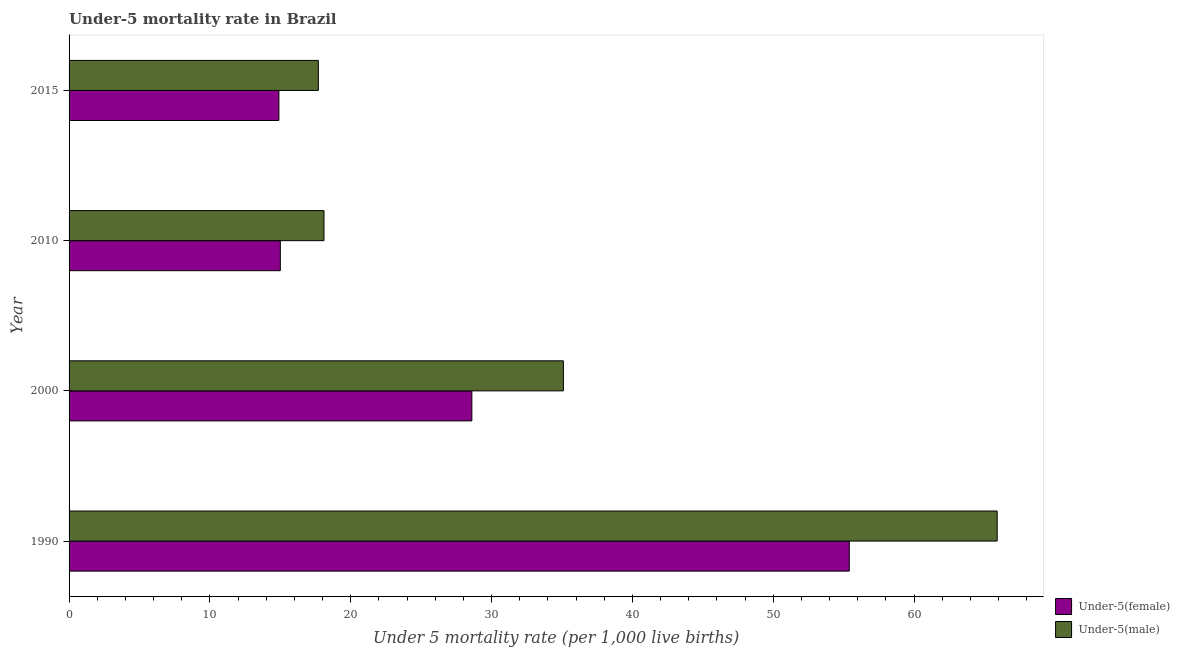How many different coloured bars are there?
Provide a short and direct response. 2. How many groups of bars are there?
Offer a terse response. 4. Are the number of bars on each tick of the Y-axis equal?
Your response must be concise. Yes. How many bars are there on the 2nd tick from the bottom?
Your answer should be compact. 2. What is the under-5 male mortality rate in 2015?
Keep it short and to the point. 17.7. Across all years, what is the maximum under-5 female mortality rate?
Provide a short and direct response. 55.4. Across all years, what is the minimum under-5 female mortality rate?
Make the answer very short. 14.9. In which year was the under-5 female mortality rate minimum?
Make the answer very short. 2015. What is the total under-5 male mortality rate in the graph?
Ensure brevity in your answer.  136.8. What is the difference between the under-5 male mortality rate in 1990 and that in 2000?
Your answer should be compact. 30.8. What is the difference between the under-5 male mortality rate in 2010 and the under-5 female mortality rate in 2000?
Your response must be concise. -10.5. What is the average under-5 female mortality rate per year?
Ensure brevity in your answer.  28.48. What is the ratio of the under-5 female mortality rate in 1990 to that in 2000?
Your answer should be compact. 1.94. What is the difference between the highest and the second highest under-5 male mortality rate?
Your response must be concise. 30.8. What is the difference between the highest and the lowest under-5 male mortality rate?
Keep it short and to the point. 48.2. Is the sum of the under-5 female mortality rate in 1990 and 2010 greater than the maximum under-5 male mortality rate across all years?
Your response must be concise. Yes. What does the 1st bar from the top in 2010 represents?
Offer a very short reply. Under-5(male). What does the 2nd bar from the bottom in 2000 represents?
Keep it short and to the point. Under-5(male). Are all the bars in the graph horizontal?
Offer a very short reply. Yes. How many years are there in the graph?
Keep it short and to the point. 4. Are the values on the major ticks of X-axis written in scientific E-notation?
Ensure brevity in your answer.  No. What is the title of the graph?
Offer a terse response. Under-5 mortality rate in Brazil. What is the label or title of the X-axis?
Offer a very short reply. Under 5 mortality rate (per 1,0 live births). What is the Under 5 mortality rate (per 1,000 live births) of Under-5(female) in 1990?
Offer a very short reply. 55.4. What is the Under 5 mortality rate (per 1,000 live births) of Under-5(male) in 1990?
Provide a succinct answer. 65.9. What is the Under 5 mortality rate (per 1,000 live births) of Under-5(female) in 2000?
Offer a terse response. 28.6. What is the Under 5 mortality rate (per 1,000 live births) of Under-5(male) in 2000?
Give a very brief answer. 35.1. What is the Under 5 mortality rate (per 1,000 live births) in Under-5(female) in 2010?
Give a very brief answer. 15. What is the Under 5 mortality rate (per 1,000 live births) in Under-5(female) in 2015?
Give a very brief answer. 14.9. Across all years, what is the maximum Under 5 mortality rate (per 1,000 live births) of Under-5(female)?
Give a very brief answer. 55.4. Across all years, what is the maximum Under 5 mortality rate (per 1,000 live births) in Under-5(male)?
Your answer should be very brief. 65.9. Across all years, what is the minimum Under 5 mortality rate (per 1,000 live births) of Under-5(male)?
Your answer should be very brief. 17.7. What is the total Under 5 mortality rate (per 1,000 live births) of Under-5(female) in the graph?
Offer a very short reply. 113.9. What is the total Under 5 mortality rate (per 1,000 live births) of Under-5(male) in the graph?
Your answer should be compact. 136.8. What is the difference between the Under 5 mortality rate (per 1,000 live births) in Under-5(female) in 1990 and that in 2000?
Your answer should be compact. 26.8. What is the difference between the Under 5 mortality rate (per 1,000 live births) of Under-5(male) in 1990 and that in 2000?
Give a very brief answer. 30.8. What is the difference between the Under 5 mortality rate (per 1,000 live births) of Under-5(female) in 1990 and that in 2010?
Provide a short and direct response. 40.4. What is the difference between the Under 5 mortality rate (per 1,000 live births) in Under-5(male) in 1990 and that in 2010?
Make the answer very short. 47.8. What is the difference between the Under 5 mortality rate (per 1,000 live births) in Under-5(female) in 1990 and that in 2015?
Provide a succinct answer. 40.5. What is the difference between the Under 5 mortality rate (per 1,000 live births) in Under-5(male) in 1990 and that in 2015?
Offer a terse response. 48.2. What is the difference between the Under 5 mortality rate (per 1,000 live births) in Under-5(female) in 2000 and that in 2010?
Provide a short and direct response. 13.6. What is the difference between the Under 5 mortality rate (per 1,000 live births) in Under-5(male) in 2000 and that in 2010?
Ensure brevity in your answer.  17. What is the difference between the Under 5 mortality rate (per 1,000 live births) of Under-5(female) in 2000 and that in 2015?
Keep it short and to the point. 13.7. What is the difference between the Under 5 mortality rate (per 1,000 live births) in Under-5(male) in 2000 and that in 2015?
Keep it short and to the point. 17.4. What is the difference between the Under 5 mortality rate (per 1,000 live births) in Under-5(female) in 2010 and that in 2015?
Ensure brevity in your answer.  0.1. What is the difference between the Under 5 mortality rate (per 1,000 live births) in Under-5(female) in 1990 and the Under 5 mortality rate (per 1,000 live births) in Under-5(male) in 2000?
Offer a terse response. 20.3. What is the difference between the Under 5 mortality rate (per 1,000 live births) of Under-5(female) in 1990 and the Under 5 mortality rate (per 1,000 live births) of Under-5(male) in 2010?
Offer a very short reply. 37.3. What is the difference between the Under 5 mortality rate (per 1,000 live births) in Under-5(female) in 1990 and the Under 5 mortality rate (per 1,000 live births) in Under-5(male) in 2015?
Provide a succinct answer. 37.7. What is the difference between the Under 5 mortality rate (per 1,000 live births) of Under-5(female) in 2000 and the Under 5 mortality rate (per 1,000 live births) of Under-5(male) in 2010?
Your answer should be very brief. 10.5. What is the difference between the Under 5 mortality rate (per 1,000 live births) in Under-5(female) in 2000 and the Under 5 mortality rate (per 1,000 live births) in Under-5(male) in 2015?
Your answer should be very brief. 10.9. What is the average Under 5 mortality rate (per 1,000 live births) in Under-5(female) per year?
Give a very brief answer. 28.48. What is the average Under 5 mortality rate (per 1,000 live births) of Under-5(male) per year?
Make the answer very short. 34.2. In the year 1990, what is the difference between the Under 5 mortality rate (per 1,000 live births) of Under-5(female) and Under 5 mortality rate (per 1,000 live births) of Under-5(male)?
Your answer should be very brief. -10.5. In the year 2010, what is the difference between the Under 5 mortality rate (per 1,000 live births) in Under-5(female) and Under 5 mortality rate (per 1,000 live births) in Under-5(male)?
Make the answer very short. -3.1. In the year 2015, what is the difference between the Under 5 mortality rate (per 1,000 live births) of Under-5(female) and Under 5 mortality rate (per 1,000 live births) of Under-5(male)?
Provide a short and direct response. -2.8. What is the ratio of the Under 5 mortality rate (per 1,000 live births) of Under-5(female) in 1990 to that in 2000?
Your answer should be compact. 1.94. What is the ratio of the Under 5 mortality rate (per 1,000 live births) in Under-5(male) in 1990 to that in 2000?
Give a very brief answer. 1.88. What is the ratio of the Under 5 mortality rate (per 1,000 live births) in Under-5(female) in 1990 to that in 2010?
Keep it short and to the point. 3.69. What is the ratio of the Under 5 mortality rate (per 1,000 live births) in Under-5(male) in 1990 to that in 2010?
Offer a very short reply. 3.64. What is the ratio of the Under 5 mortality rate (per 1,000 live births) in Under-5(female) in 1990 to that in 2015?
Ensure brevity in your answer.  3.72. What is the ratio of the Under 5 mortality rate (per 1,000 live births) of Under-5(male) in 1990 to that in 2015?
Provide a short and direct response. 3.72. What is the ratio of the Under 5 mortality rate (per 1,000 live births) in Under-5(female) in 2000 to that in 2010?
Provide a succinct answer. 1.91. What is the ratio of the Under 5 mortality rate (per 1,000 live births) in Under-5(male) in 2000 to that in 2010?
Give a very brief answer. 1.94. What is the ratio of the Under 5 mortality rate (per 1,000 live births) of Under-5(female) in 2000 to that in 2015?
Your answer should be compact. 1.92. What is the ratio of the Under 5 mortality rate (per 1,000 live births) in Under-5(male) in 2000 to that in 2015?
Ensure brevity in your answer.  1.98. What is the ratio of the Under 5 mortality rate (per 1,000 live births) of Under-5(female) in 2010 to that in 2015?
Offer a very short reply. 1.01. What is the ratio of the Under 5 mortality rate (per 1,000 live births) in Under-5(male) in 2010 to that in 2015?
Give a very brief answer. 1.02. What is the difference between the highest and the second highest Under 5 mortality rate (per 1,000 live births) of Under-5(female)?
Provide a short and direct response. 26.8. What is the difference between the highest and the second highest Under 5 mortality rate (per 1,000 live births) in Under-5(male)?
Your answer should be very brief. 30.8. What is the difference between the highest and the lowest Under 5 mortality rate (per 1,000 live births) in Under-5(female)?
Keep it short and to the point. 40.5. What is the difference between the highest and the lowest Under 5 mortality rate (per 1,000 live births) of Under-5(male)?
Provide a succinct answer. 48.2. 